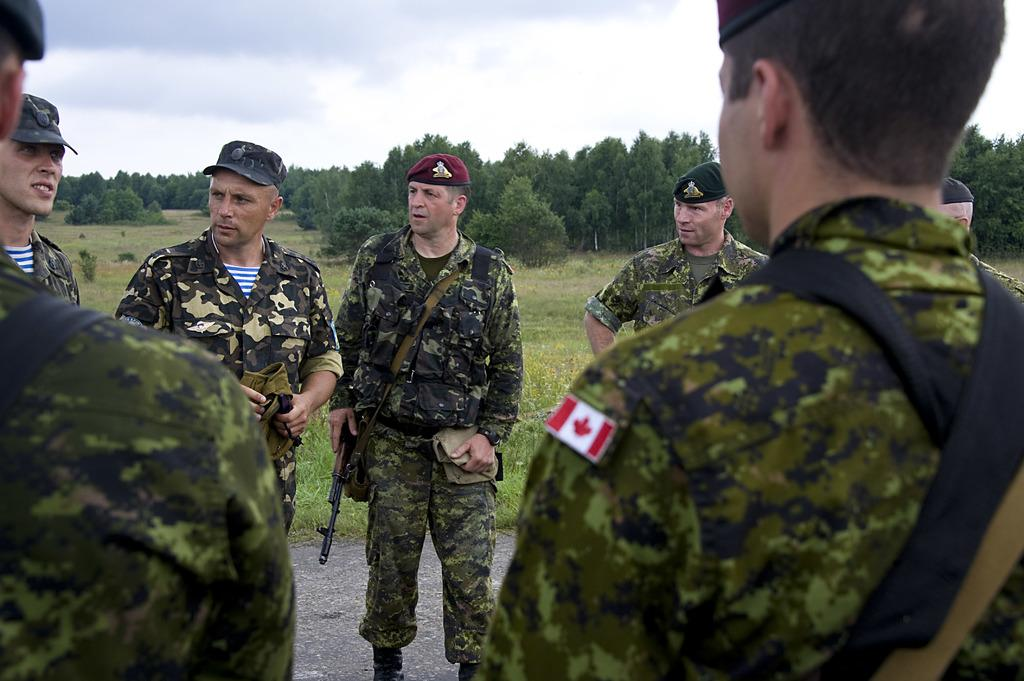How many persons are in the image? There are persons standing in the image. What are the persons holding in the image? The persons are holding guns. What can be seen in the background of the image? There are trees, plants, grass, and sky visible in the background of the image. What is the condition of the sky in the image? Clouds are visible in the sky. What type of rock can be seen changing colors in the image? There is no rock present in the image, and therefore no such color-changing activity can be observed. What word is being spelled out by the clouds in the image? There is no word being spelled out by the clouds in the image; they are simply visible in the sky. 